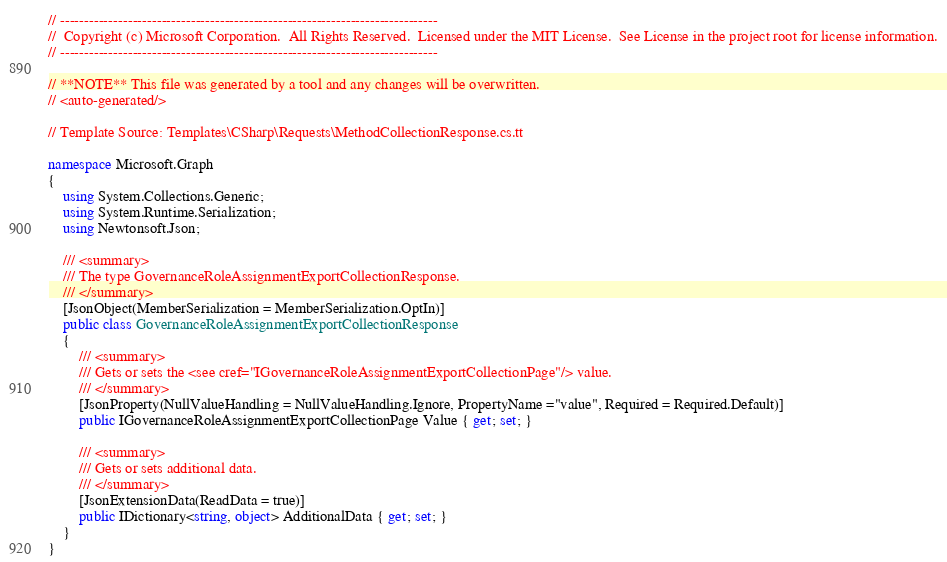<code> <loc_0><loc_0><loc_500><loc_500><_C#_>// ------------------------------------------------------------------------------
//  Copyright (c) Microsoft Corporation.  All Rights Reserved.  Licensed under the MIT License.  See License in the project root for license information.
// ------------------------------------------------------------------------------

// **NOTE** This file was generated by a tool and any changes will be overwritten.
// <auto-generated/>

// Template Source: Templates\CSharp\Requests\MethodCollectionResponse.cs.tt

namespace Microsoft.Graph
{
    using System.Collections.Generic;
    using System.Runtime.Serialization;
    using Newtonsoft.Json;

    /// <summary>
    /// The type GovernanceRoleAssignmentExportCollectionResponse.
    /// </summary>
    [JsonObject(MemberSerialization = MemberSerialization.OptIn)]
    public class GovernanceRoleAssignmentExportCollectionResponse
    {
        /// <summary>
        /// Gets or sets the <see cref="IGovernanceRoleAssignmentExportCollectionPage"/> value.
        /// </summary>
        [JsonProperty(NullValueHandling = NullValueHandling.Ignore, PropertyName ="value", Required = Required.Default)]
        public IGovernanceRoleAssignmentExportCollectionPage Value { get; set; }
        
        /// <summary>
        /// Gets or sets additional data.
        /// </summary>
        [JsonExtensionData(ReadData = true)]
        public IDictionary<string, object> AdditionalData { get; set; }
    }
}
</code> 